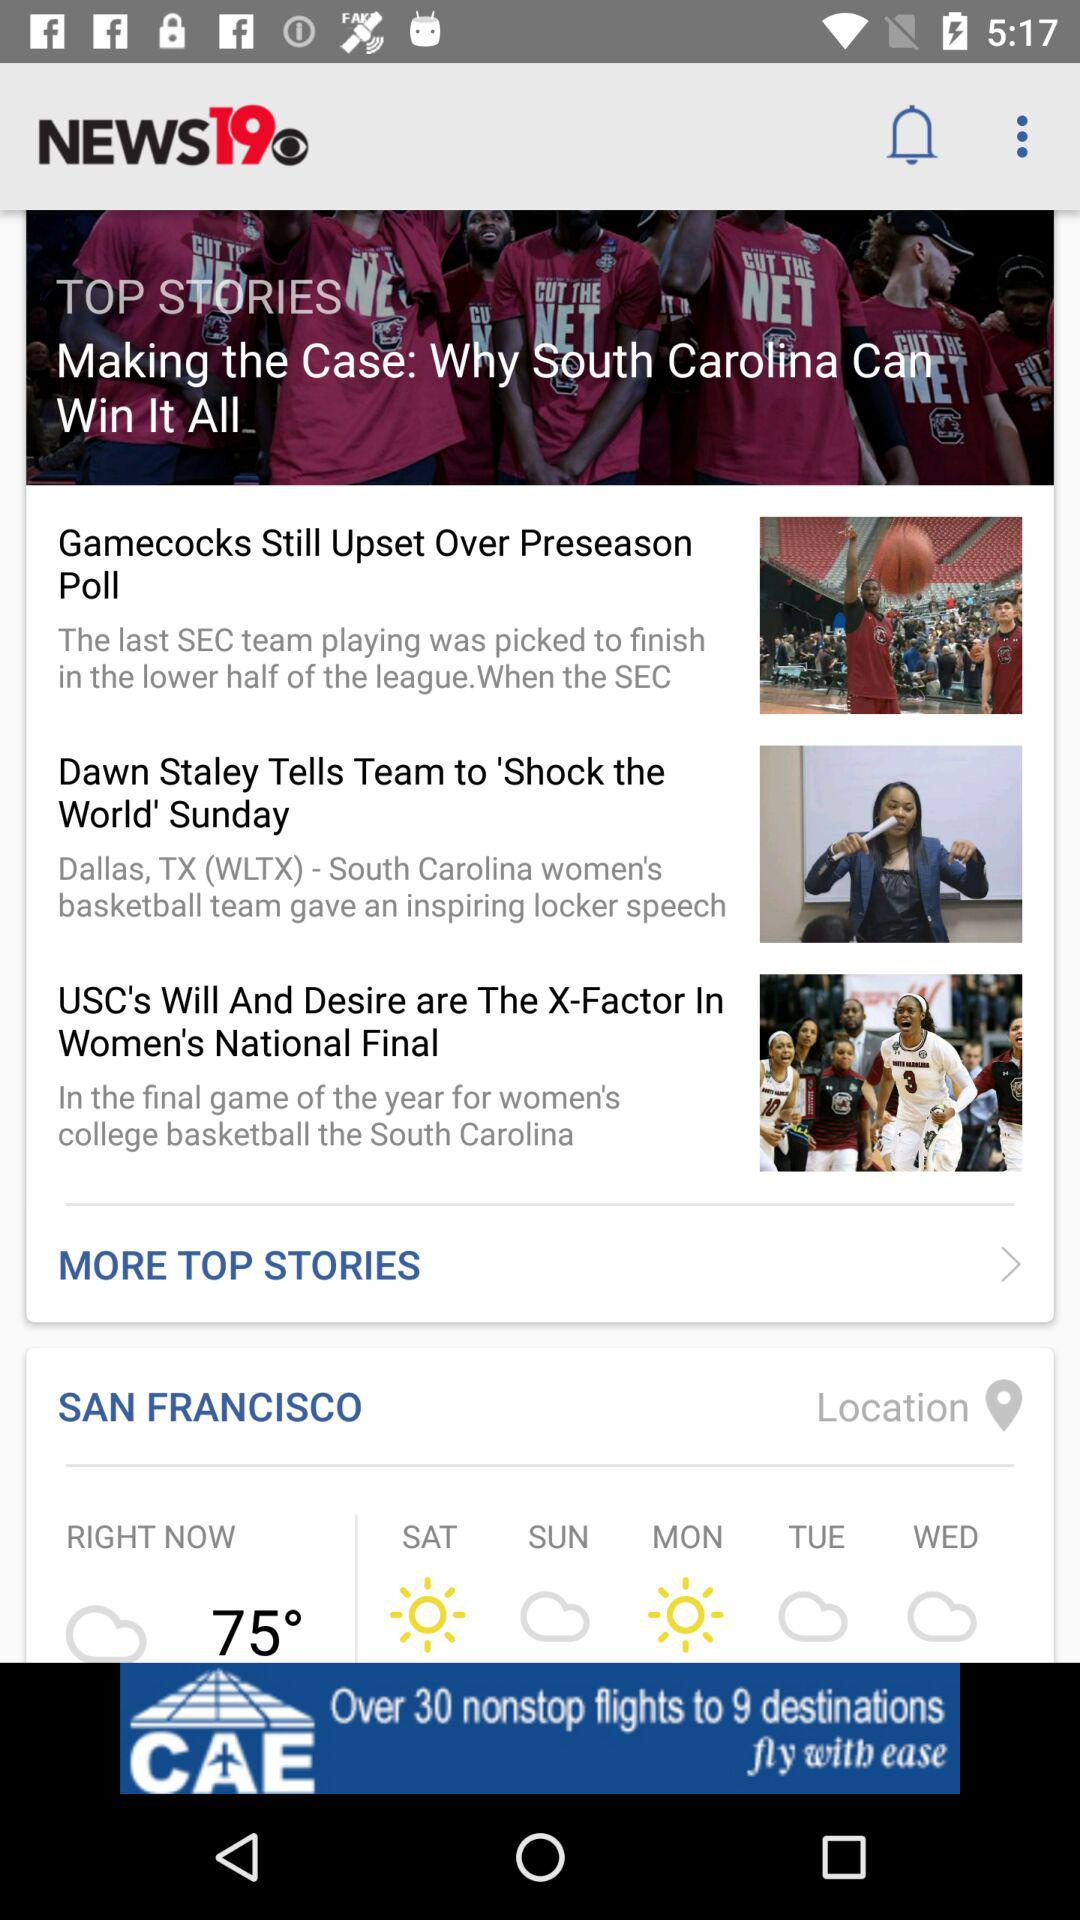How many more articles are there after the first article?
Answer the question using a single word or phrase. 2 